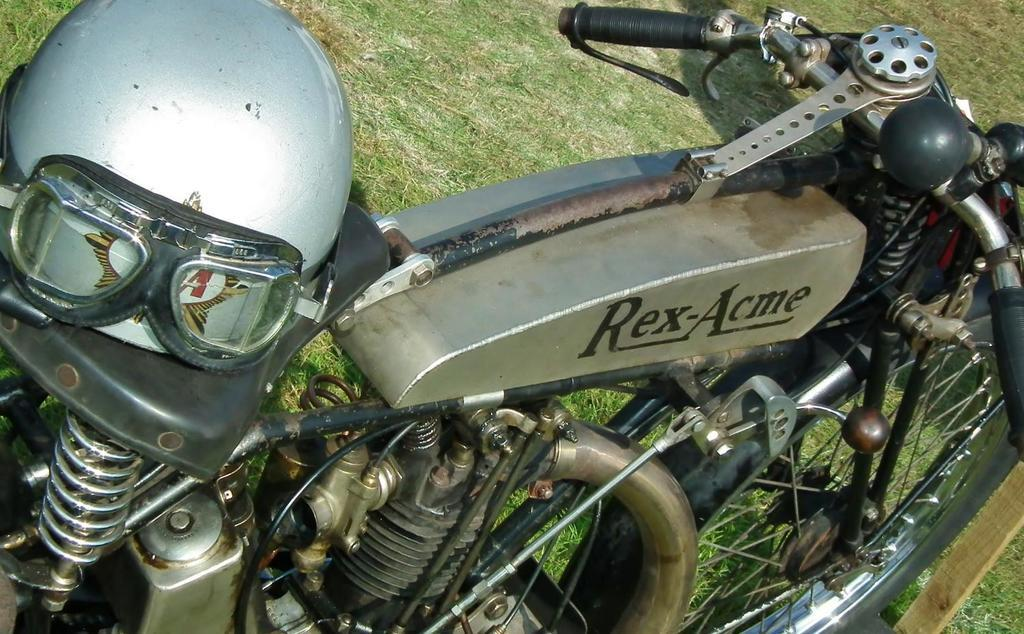What type of vehicle is in the picture? There is a motorcycle in the picture. What is a key feature of the motorcycle? The motorcycle has an engine. How can the rider control the motorcycle? The motorcycle has a handle for the rider to steer. Is there any branding or identification on the motorcycle? Yes, there is a logo on the motorcycle. What is provided for the rider's safety? There is a helmet in the picture. What type of surface is visible in the picture? There is grass on the floor. What type of dress is the motorcycle wearing in the picture? Motorcycles do not wear dresses; they are vehicles and do not have clothing. 